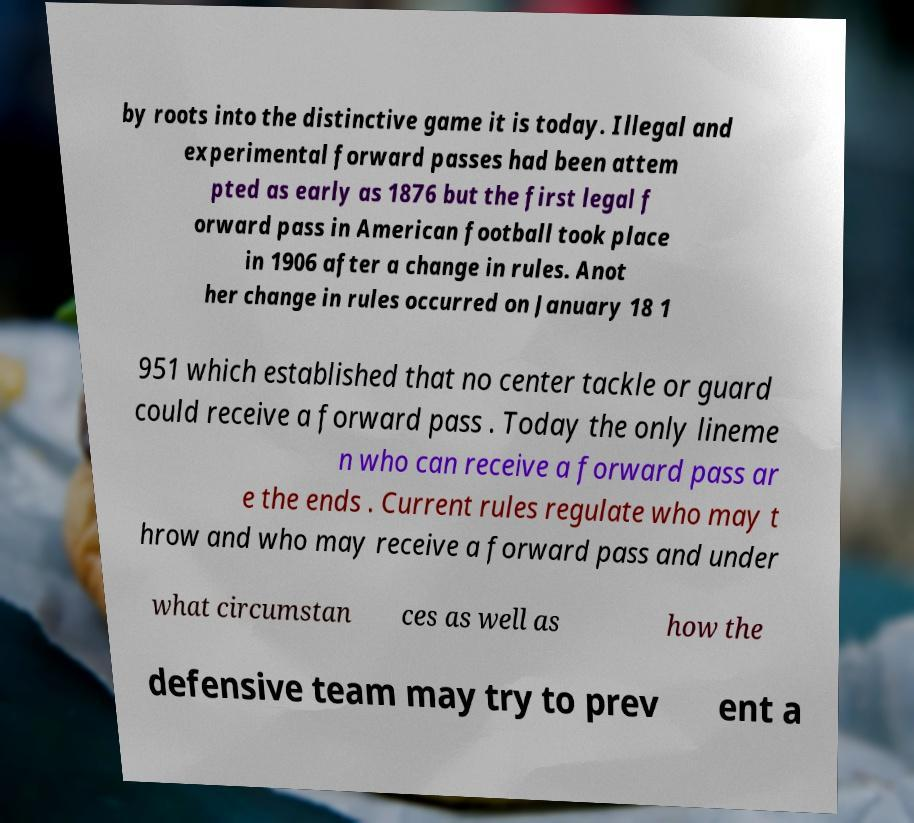Could you extract and type out the text from this image? by roots into the distinctive game it is today. Illegal and experimental forward passes had been attem pted as early as 1876 but the first legal f orward pass in American football took place in 1906 after a change in rules. Anot her change in rules occurred on January 18 1 951 which established that no center tackle or guard could receive a forward pass . Today the only lineme n who can receive a forward pass ar e the ends . Current rules regulate who may t hrow and who may receive a forward pass and under what circumstan ces as well as how the defensive team may try to prev ent a 